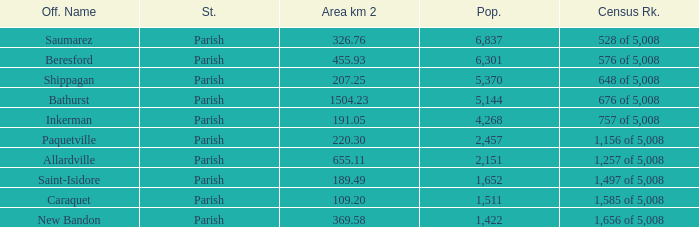What is the Area of the Saint-Isidore Parish with a Population smaller than 4,268? 189.49. 